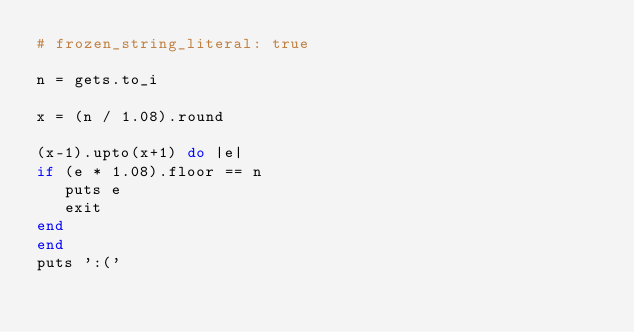Convert code to text. <code><loc_0><loc_0><loc_500><loc_500><_Ruby_># frozen_string_literal: true

n = gets.to_i

x = (n / 1.08).round

(x-1).upto(x+1) do |e|
if (e * 1.08).floor == n
   puts e
   exit
end
end
puts ':('
</code> 